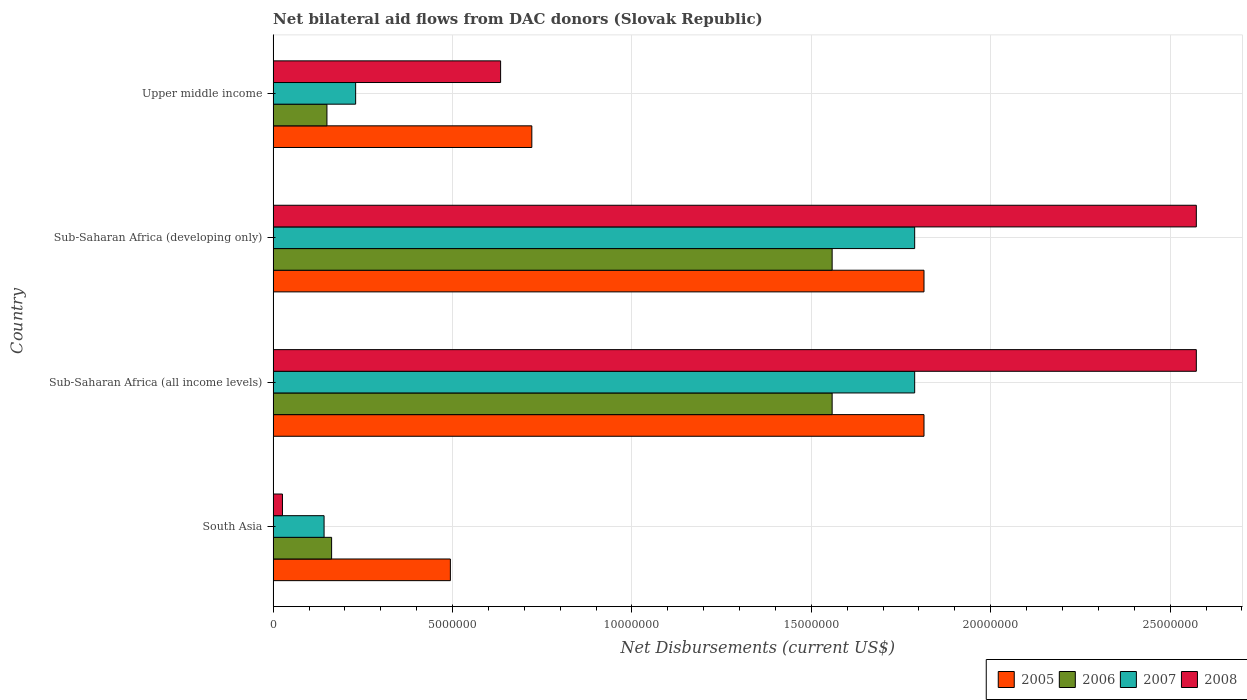How many different coloured bars are there?
Offer a terse response. 4. Are the number of bars per tick equal to the number of legend labels?
Offer a terse response. Yes. Are the number of bars on each tick of the Y-axis equal?
Give a very brief answer. Yes. How many bars are there on the 4th tick from the top?
Your answer should be compact. 4. In how many cases, is the number of bars for a given country not equal to the number of legend labels?
Offer a very short reply. 0. What is the net bilateral aid flows in 2007 in Sub-Saharan Africa (all income levels)?
Offer a very short reply. 1.79e+07. Across all countries, what is the maximum net bilateral aid flows in 2007?
Keep it short and to the point. 1.79e+07. Across all countries, what is the minimum net bilateral aid flows in 2008?
Your response must be concise. 2.60e+05. In which country was the net bilateral aid flows in 2008 maximum?
Give a very brief answer. Sub-Saharan Africa (all income levels). In which country was the net bilateral aid flows in 2008 minimum?
Provide a short and direct response. South Asia. What is the total net bilateral aid flows in 2006 in the graph?
Ensure brevity in your answer.  3.43e+07. What is the difference between the net bilateral aid flows in 2005 in Sub-Saharan Africa (all income levels) and that in Upper middle income?
Make the answer very short. 1.09e+07. What is the difference between the net bilateral aid flows in 2007 in Sub-Saharan Africa (developing only) and the net bilateral aid flows in 2008 in Upper middle income?
Make the answer very short. 1.15e+07. What is the average net bilateral aid flows in 2007 per country?
Provide a short and direct response. 9.87e+06. What is the difference between the net bilateral aid flows in 2005 and net bilateral aid flows in 2006 in South Asia?
Keep it short and to the point. 3.31e+06. What is the ratio of the net bilateral aid flows in 2007 in Sub-Saharan Africa (all income levels) to that in Upper middle income?
Ensure brevity in your answer.  7.77. What is the difference between the highest and the second highest net bilateral aid flows in 2006?
Give a very brief answer. 0. What is the difference between the highest and the lowest net bilateral aid flows in 2006?
Offer a very short reply. 1.41e+07. Is it the case that in every country, the sum of the net bilateral aid flows in 2005 and net bilateral aid flows in 2006 is greater than the sum of net bilateral aid flows in 2007 and net bilateral aid flows in 2008?
Your response must be concise. No. Is it the case that in every country, the sum of the net bilateral aid flows in 2005 and net bilateral aid flows in 2007 is greater than the net bilateral aid flows in 2006?
Ensure brevity in your answer.  Yes. How many bars are there?
Offer a very short reply. 16. How many countries are there in the graph?
Your answer should be compact. 4. Are the values on the major ticks of X-axis written in scientific E-notation?
Make the answer very short. No. Does the graph contain any zero values?
Your answer should be compact. No. Where does the legend appear in the graph?
Your response must be concise. Bottom right. How many legend labels are there?
Your answer should be very brief. 4. What is the title of the graph?
Give a very brief answer. Net bilateral aid flows from DAC donors (Slovak Republic). What is the label or title of the X-axis?
Keep it short and to the point. Net Disbursements (current US$). What is the Net Disbursements (current US$) of 2005 in South Asia?
Your response must be concise. 4.94e+06. What is the Net Disbursements (current US$) in 2006 in South Asia?
Keep it short and to the point. 1.63e+06. What is the Net Disbursements (current US$) in 2007 in South Asia?
Keep it short and to the point. 1.42e+06. What is the Net Disbursements (current US$) of 2005 in Sub-Saharan Africa (all income levels)?
Keep it short and to the point. 1.81e+07. What is the Net Disbursements (current US$) of 2006 in Sub-Saharan Africa (all income levels)?
Provide a succinct answer. 1.56e+07. What is the Net Disbursements (current US$) of 2007 in Sub-Saharan Africa (all income levels)?
Your answer should be very brief. 1.79e+07. What is the Net Disbursements (current US$) in 2008 in Sub-Saharan Africa (all income levels)?
Provide a short and direct response. 2.57e+07. What is the Net Disbursements (current US$) in 2005 in Sub-Saharan Africa (developing only)?
Keep it short and to the point. 1.81e+07. What is the Net Disbursements (current US$) of 2006 in Sub-Saharan Africa (developing only)?
Offer a very short reply. 1.56e+07. What is the Net Disbursements (current US$) in 2007 in Sub-Saharan Africa (developing only)?
Your answer should be very brief. 1.79e+07. What is the Net Disbursements (current US$) of 2008 in Sub-Saharan Africa (developing only)?
Keep it short and to the point. 2.57e+07. What is the Net Disbursements (current US$) in 2005 in Upper middle income?
Make the answer very short. 7.21e+06. What is the Net Disbursements (current US$) of 2006 in Upper middle income?
Your answer should be very brief. 1.50e+06. What is the Net Disbursements (current US$) in 2007 in Upper middle income?
Ensure brevity in your answer.  2.30e+06. What is the Net Disbursements (current US$) in 2008 in Upper middle income?
Offer a very short reply. 6.34e+06. Across all countries, what is the maximum Net Disbursements (current US$) of 2005?
Make the answer very short. 1.81e+07. Across all countries, what is the maximum Net Disbursements (current US$) in 2006?
Your answer should be very brief. 1.56e+07. Across all countries, what is the maximum Net Disbursements (current US$) in 2007?
Provide a short and direct response. 1.79e+07. Across all countries, what is the maximum Net Disbursements (current US$) in 2008?
Keep it short and to the point. 2.57e+07. Across all countries, what is the minimum Net Disbursements (current US$) of 2005?
Offer a very short reply. 4.94e+06. Across all countries, what is the minimum Net Disbursements (current US$) of 2006?
Ensure brevity in your answer.  1.50e+06. Across all countries, what is the minimum Net Disbursements (current US$) in 2007?
Your answer should be compact. 1.42e+06. Across all countries, what is the minimum Net Disbursements (current US$) in 2008?
Make the answer very short. 2.60e+05. What is the total Net Disbursements (current US$) in 2005 in the graph?
Your response must be concise. 4.84e+07. What is the total Net Disbursements (current US$) of 2006 in the graph?
Keep it short and to the point. 3.43e+07. What is the total Net Disbursements (current US$) of 2007 in the graph?
Your response must be concise. 3.95e+07. What is the total Net Disbursements (current US$) of 2008 in the graph?
Ensure brevity in your answer.  5.81e+07. What is the difference between the Net Disbursements (current US$) of 2005 in South Asia and that in Sub-Saharan Africa (all income levels)?
Give a very brief answer. -1.32e+07. What is the difference between the Net Disbursements (current US$) in 2006 in South Asia and that in Sub-Saharan Africa (all income levels)?
Give a very brief answer. -1.40e+07. What is the difference between the Net Disbursements (current US$) of 2007 in South Asia and that in Sub-Saharan Africa (all income levels)?
Your answer should be compact. -1.65e+07. What is the difference between the Net Disbursements (current US$) in 2008 in South Asia and that in Sub-Saharan Africa (all income levels)?
Your answer should be very brief. -2.55e+07. What is the difference between the Net Disbursements (current US$) in 2005 in South Asia and that in Sub-Saharan Africa (developing only)?
Your answer should be very brief. -1.32e+07. What is the difference between the Net Disbursements (current US$) of 2006 in South Asia and that in Sub-Saharan Africa (developing only)?
Offer a terse response. -1.40e+07. What is the difference between the Net Disbursements (current US$) in 2007 in South Asia and that in Sub-Saharan Africa (developing only)?
Provide a succinct answer. -1.65e+07. What is the difference between the Net Disbursements (current US$) in 2008 in South Asia and that in Sub-Saharan Africa (developing only)?
Your answer should be very brief. -2.55e+07. What is the difference between the Net Disbursements (current US$) of 2005 in South Asia and that in Upper middle income?
Make the answer very short. -2.27e+06. What is the difference between the Net Disbursements (current US$) of 2007 in South Asia and that in Upper middle income?
Provide a short and direct response. -8.80e+05. What is the difference between the Net Disbursements (current US$) in 2008 in South Asia and that in Upper middle income?
Make the answer very short. -6.08e+06. What is the difference between the Net Disbursements (current US$) of 2005 in Sub-Saharan Africa (all income levels) and that in Sub-Saharan Africa (developing only)?
Make the answer very short. 0. What is the difference between the Net Disbursements (current US$) in 2006 in Sub-Saharan Africa (all income levels) and that in Sub-Saharan Africa (developing only)?
Provide a succinct answer. 0. What is the difference between the Net Disbursements (current US$) in 2008 in Sub-Saharan Africa (all income levels) and that in Sub-Saharan Africa (developing only)?
Your answer should be very brief. 0. What is the difference between the Net Disbursements (current US$) in 2005 in Sub-Saharan Africa (all income levels) and that in Upper middle income?
Your response must be concise. 1.09e+07. What is the difference between the Net Disbursements (current US$) in 2006 in Sub-Saharan Africa (all income levels) and that in Upper middle income?
Offer a terse response. 1.41e+07. What is the difference between the Net Disbursements (current US$) in 2007 in Sub-Saharan Africa (all income levels) and that in Upper middle income?
Offer a terse response. 1.56e+07. What is the difference between the Net Disbursements (current US$) in 2008 in Sub-Saharan Africa (all income levels) and that in Upper middle income?
Give a very brief answer. 1.94e+07. What is the difference between the Net Disbursements (current US$) in 2005 in Sub-Saharan Africa (developing only) and that in Upper middle income?
Make the answer very short. 1.09e+07. What is the difference between the Net Disbursements (current US$) in 2006 in Sub-Saharan Africa (developing only) and that in Upper middle income?
Provide a succinct answer. 1.41e+07. What is the difference between the Net Disbursements (current US$) of 2007 in Sub-Saharan Africa (developing only) and that in Upper middle income?
Your answer should be compact. 1.56e+07. What is the difference between the Net Disbursements (current US$) of 2008 in Sub-Saharan Africa (developing only) and that in Upper middle income?
Give a very brief answer. 1.94e+07. What is the difference between the Net Disbursements (current US$) in 2005 in South Asia and the Net Disbursements (current US$) in 2006 in Sub-Saharan Africa (all income levels)?
Give a very brief answer. -1.06e+07. What is the difference between the Net Disbursements (current US$) in 2005 in South Asia and the Net Disbursements (current US$) in 2007 in Sub-Saharan Africa (all income levels)?
Provide a succinct answer. -1.29e+07. What is the difference between the Net Disbursements (current US$) in 2005 in South Asia and the Net Disbursements (current US$) in 2008 in Sub-Saharan Africa (all income levels)?
Offer a very short reply. -2.08e+07. What is the difference between the Net Disbursements (current US$) in 2006 in South Asia and the Net Disbursements (current US$) in 2007 in Sub-Saharan Africa (all income levels)?
Provide a short and direct response. -1.62e+07. What is the difference between the Net Disbursements (current US$) in 2006 in South Asia and the Net Disbursements (current US$) in 2008 in Sub-Saharan Africa (all income levels)?
Your answer should be compact. -2.41e+07. What is the difference between the Net Disbursements (current US$) in 2007 in South Asia and the Net Disbursements (current US$) in 2008 in Sub-Saharan Africa (all income levels)?
Give a very brief answer. -2.43e+07. What is the difference between the Net Disbursements (current US$) of 2005 in South Asia and the Net Disbursements (current US$) of 2006 in Sub-Saharan Africa (developing only)?
Your answer should be very brief. -1.06e+07. What is the difference between the Net Disbursements (current US$) in 2005 in South Asia and the Net Disbursements (current US$) in 2007 in Sub-Saharan Africa (developing only)?
Keep it short and to the point. -1.29e+07. What is the difference between the Net Disbursements (current US$) of 2005 in South Asia and the Net Disbursements (current US$) of 2008 in Sub-Saharan Africa (developing only)?
Your answer should be compact. -2.08e+07. What is the difference between the Net Disbursements (current US$) in 2006 in South Asia and the Net Disbursements (current US$) in 2007 in Sub-Saharan Africa (developing only)?
Provide a succinct answer. -1.62e+07. What is the difference between the Net Disbursements (current US$) of 2006 in South Asia and the Net Disbursements (current US$) of 2008 in Sub-Saharan Africa (developing only)?
Your response must be concise. -2.41e+07. What is the difference between the Net Disbursements (current US$) of 2007 in South Asia and the Net Disbursements (current US$) of 2008 in Sub-Saharan Africa (developing only)?
Offer a very short reply. -2.43e+07. What is the difference between the Net Disbursements (current US$) of 2005 in South Asia and the Net Disbursements (current US$) of 2006 in Upper middle income?
Keep it short and to the point. 3.44e+06. What is the difference between the Net Disbursements (current US$) in 2005 in South Asia and the Net Disbursements (current US$) in 2007 in Upper middle income?
Make the answer very short. 2.64e+06. What is the difference between the Net Disbursements (current US$) of 2005 in South Asia and the Net Disbursements (current US$) of 2008 in Upper middle income?
Give a very brief answer. -1.40e+06. What is the difference between the Net Disbursements (current US$) in 2006 in South Asia and the Net Disbursements (current US$) in 2007 in Upper middle income?
Ensure brevity in your answer.  -6.70e+05. What is the difference between the Net Disbursements (current US$) in 2006 in South Asia and the Net Disbursements (current US$) in 2008 in Upper middle income?
Your answer should be compact. -4.71e+06. What is the difference between the Net Disbursements (current US$) in 2007 in South Asia and the Net Disbursements (current US$) in 2008 in Upper middle income?
Provide a short and direct response. -4.92e+06. What is the difference between the Net Disbursements (current US$) of 2005 in Sub-Saharan Africa (all income levels) and the Net Disbursements (current US$) of 2006 in Sub-Saharan Africa (developing only)?
Make the answer very short. 2.56e+06. What is the difference between the Net Disbursements (current US$) in 2005 in Sub-Saharan Africa (all income levels) and the Net Disbursements (current US$) in 2007 in Sub-Saharan Africa (developing only)?
Provide a succinct answer. 2.60e+05. What is the difference between the Net Disbursements (current US$) of 2005 in Sub-Saharan Africa (all income levels) and the Net Disbursements (current US$) of 2008 in Sub-Saharan Africa (developing only)?
Offer a very short reply. -7.59e+06. What is the difference between the Net Disbursements (current US$) of 2006 in Sub-Saharan Africa (all income levels) and the Net Disbursements (current US$) of 2007 in Sub-Saharan Africa (developing only)?
Give a very brief answer. -2.30e+06. What is the difference between the Net Disbursements (current US$) of 2006 in Sub-Saharan Africa (all income levels) and the Net Disbursements (current US$) of 2008 in Sub-Saharan Africa (developing only)?
Your response must be concise. -1.02e+07. What is the difference between the Net Disbursements (current US$) of 2007 in Sub-Saharan Africa (all income levels) and the Net Disbursements (current US$) of 2008 in Sub-Saharan Africa (developing only)?
Offer a terse response. -7.85e+06. What is the difference between the Net Disbursements (current US$) of 2005 in Sub-Saharan Africa (all income levels) and the Net Disbursements (current US$) of 2006 in Upper middle income?
Your answer should be compact. 1.66e+07. What is the difference between the Net Disbursements (current US$) of 2005 in Sub-Saharan Africa (all income levels) and the Net Disbursements (current US$) of 2007 in Upper middle income?
Provide a short and direct response. 1.58e+07. What is the difference between the Net Disbursements (current US$) of 2005 in Sub-Saharan Africa (all income levels) and the Net Disbursements (current US$) of 2008 in Upper middle income?
Keep it short and to the point. 1.18e+07. What is the difference between the Net Disbursements (current US$) in 2006 in Sub-Saharan Africa (all income levels) and the Net Disbursements (current US$) in 2007 in Upper middle income?
Provide a succinct answer. 1.33e+07. What is the difference between the Net Disbursements (current US$) of 2006 in Sub-Saharan Africa (all income levels) and the Net Disbursements (current US$) of 2008 in Upper middle income?
Make the answer very short. 9.24e+06. What is the difference between the Net Disbursements (current US$) of 2007 in Sub-Saharan Africa (all income levels) and the Net Disbursements (current US$) of 2008 in Upper middle income?
Provide a succinct answer. 1.15e+07. What is the difference between the Net Disbursements (current US$) of 2005 in Sub-Saharan Africa (developing only) and the Net Disbursements (current US$) of 2006 in Upper middle income?
Ensure brevity in your answer.  1.66e+07. What is the difference between the Net Disbursements (current US$) in 2005 in Sub-Saharan Africa (developing only) and the Net Disbursements (current US$) in 2007 in Upper middle income?
Your answer should be very brief. 1.58e+07. What is the difference between the Net Disbursements (current US$) of 2005 in Sub-Saharan Africa (developing only) and the Net Disbursements (current US$) of 2008 in Upper middle income?
Offer a very short reply. 1.18e+07. What is the difference between the Net Disbursements (current US$) of 2006 in Sub-Saharan Africa (developing only) and the Net Disbursements (current US$) of 2007 in Upper middle income?
Your response must be concise. 1.33e+07. What is the difference between the Net Disbursements (current US$) of 2006 in Sub-Saharan Africa (developing only) and the Net Disbursements (current US$) of 2008 in Upper middle income?
Provide a succinct answer. 9.24e+06. What is the difference between the Net Disbursements (current US$) of 2007 in Sub-Saharan Africa (developing only) and the Net Disbursements (current US$) of 2008 in Upper middle income?
Keep it short and to the point. 1.15e+07. What is the average Net Disbursements (current US$) in 2005 per country?
Offer a terse response. 1.21e+07. What is the average Net Disbursements (current US$) of 2006 per country?
Ensure brevity in your answer.  8.57e+06. What is the average Net Disbursements (current US$) in 2007 per country?
Ensure brevity in your answer.  9.87e+06. What is the average Net Disbursements (current US$) in 2008 per country?
Make the answer very short. 1.45e+07. What is the difference between the Net Disbursements (current US$) in 2005 and Net Disbursements (current US$) in 2006 in South Asia?
Give a very brief answer. 3.31e+06. What is the difference between the Net Disbursements (current US$) in 2005 and Net Disbursements (current US$) in 2007 in South Asia?
Your answer should be compact. 3.52e+06. What is the difference between the Net Disbursements (current US$) in 2005 and Net Disbursements (current US$) in 2008 in South Asia?
Make the answer very short. 4.68e+06. What is the difference between the Net Disbursements (current US$) in 2006 and Net Disbursements (current US$) in 2007 in South Asia?
Keep it short and to the point. 2.10e+05. What is the difference between the Net Disbursements (current US$) of 2006 and Net Disbursements (current US$) of 2008 in South Asia?
Make the answer very short. 1.37e+06. What is the difference between the Net Disbursements (current US$) in 2007 and Net Disbursements (current US$) in 2008 in South Asia?
Your answer should be very brief. 1.16e+06. What is the difference between the Net Disbursements (current US$) in 2005 and Net Disbursements (current US$) in 2006 in Sub-Saharan Africa (all income levels)?
Keep it short and to the point. 2.56e+06. What is the difference between the Net Disbursements (current US$) of 2005 and Net Disbursements (current US$) of 2007 in Sub-Saharan Africa (all income levels)?
Your response must be concise. 2.60e+05. What is the difference between the Net Disbursements (current US$) of 2005 and Net Disbursements (current US$) of 2008 in Sub-Saharan Africa (all income levels)?
Offer a terse response. -7.59e+06. What is the difference between the Net Disbursements (current US$) of 2006 and Net Disbursements (current US$) of 2007 in Sub-Saharan Africa (all income levels)?
Your response must be concise. -2.30e+06. What is the difference between the Net Disbursements (current US$) in 2006 and Net Disbursements (current US$) in 2008 in Sub-Saharan Africa (all income levels)?
Provide a short and direct response. -1.02e+07. What is the difference between the Net Disbursements (current US$) in 2007 and Net Disbursements (current US$) in 2008 in Sub-Saharan Africa (all income levels)?
Your response must be concise. -7.85e+06. What is the difference between the Net Disbursements (current US$) in 2005 and Net Disbursements (current US$) in 2006 in Sub-Saharan Africa (developing only)?
Offer a very short reply. 2.56e+06. What is the difference between the Net Disbursements (current US$) of 2005 and Net Disbursements (current US$) of 2008 in Sub-Saharan Africa (developing only)?
Provide a short and direct response. -7.59e+06. What is the difference between the Net Disbursements (current US$) of 2006 and Net Disbursements (current US$) of 2007 in Sub-Saharan Africa (developing only)?
Provide a short and direct response. -2.30e+06. What is the difference between the Net Disbursements (current US$) of 2006 and Net Disbursements (current US$) of 2008 in Sub-Saharan Africa (developing only)?
Offer a terse response. -1.02e+07. What is the difference between the Net Disbursements (current US$) of 2007 and Net Disbursements (current US$) of 2008 in Sub-Saharan Africa (developing only)?
Your answer should be very brief. -7.85e+06. What is the difference between the Net Disbursements (current US$) in 2005 and Net Disbursements (current US$) in 2006 in Upper middle income?
Give a very brief answer. 5.71e+06. What is the difference between the Net Disbursements (current US$) in 2005 and Net Disbursements (current US$) in 2007 in Upper middle income?
Ensure brevity in your answer.  4.91e+06. What is the difference between the Net Disbursements (current US$) of 2005 and Net Disbursements (current US$) of 2008 in Upper middle income?
Provide a short and direct response. 8.70e+05. What is the difference between the Net Disbursements (current US$) of 2006 and Net Disbursements (current US$) of 2007 in Upper middle income?
Your response must be concise. -8.00e+05. What is the difference between the Net Disbursements (current US$) in 2006 and Net Disbursements (current US$) in 2008 in Upper middle income?
Give a very brief answer. -4.84e+06. What is the difference between the Net Disbursements (current US$) in 2007 and Net Disbursements (current US$) in 2008 in Upper middle income?
Your answer should be very brief. -4.04e+06. What is the ratio of the Net Disbursements (current US$) in 2005 in South Asia to that in Sub-Saharan Africa (all income levels)?
Provide a succinct answer. 0.27. What is the ratio of the Net Disbursements (current US$) of 2006 in South Asia to that in Sub-Saharan Africa (all income levels)?
Your response must be concise. 0.1. What is the ratio of the Net Disbursements (current US$) in 2007 in South Asia to that in Sub-Saharan Africa (all income levels)?
Keep it short and to the point. 0.08. What is the ratio of the Net Disbursements (current US$) of 2008 in South Asia to that in Sub-Saharan Africa (all income levels)?
Your response must be concise. 0.01. What is the ratio of the Net Disbursements (current US$) in 2005 in South Asia to that in Sub-Saharan Africa (developing only)?
Your response must be concise. 0.27. What is the ratio of the Net Disbursements (current US$) of 2006 in South Asia to that in Sub-Saharan Africa (developing only)?
Your answer should be very brief. 0.1. What is the ratio of the Net Disbursements (current US$) in 2007 in South Asia to that in Sub-Saharan Africa (developing only)?
Your answer should be compact. 0.08. What is the ratio of the Net Disbursements (current US$) in 2008 in South Asia to that in Sub-Saharan Africa (developing only)?
Keep it short and to the point. 0.01. What is the ratio of the Net Disbursements (current US$) of 2005 in South Asia to that in Upper middle income?
Ensure brevity in your answer.  0.69. What is the ratio of the Net Disbursements (current US$) in 2006 in South Asia to that in Upper middle income?
Give a very brief answer. 1.09. What is the ratio of the Net Disbursements (current US$) in 2007 in South Asia to that in Upper middle income?
Make the answer very short. 0.62. What is the ratio of the Net Disbursements (current US$) in 2008 in South Asia to that in Upper middle income?
Your answer should be very brief. 0.04. What is the ratio of the Net Disbursements (current US$) of 2005 in Sub-Saharan Africa (all income levels) to that in Sub-Saharan Africa (developing only)?
Offer a very short reply. 1. What is the ratio of the Net Disbursements (current US$) of 2005 in Sub-Saharan Africa (all income levels) to that in Upper middle income?
Your response must be concise. 2.52. What is the ratio of the Net Disbursements (current US$) of 2006 in Sub-Saharan Africa (all income levels) to that in Upper middle income?
Offer a very short reply. 10.39. What is the ratio of the Net Disbursements (current US$) of 2007 in Sub-Saharan Africa (all income levels) to that in Upper middle income?
Give a very brief answer. 7.77. What is the ratio of the Net Disbursements (current US$) of 2008 in Sub-Saharan Africa (all income levels) to that in Upper middle income?
Give a very brief answer. 4.06. What is the ratio of the Net Disbursements (current US$) in 2005 in Sub-Saharan Africa (developing only) to that in Upper middle income?
Your response must be concise. 2.52. What is the ratio of the Net Disbursements (current US$) in 2006 in Sub-Saharan Africa (developing only) to that in Upper middle income?
Make the answer very short. 10.39. What is the ratio of the Net Disbursements (current US$) in 2007 in Sub-Saharan Africa (developing only) to that in Upper middle income?
Your answer should be compact. 7.77. What is the ratio of the Net Disbursements (current US$) of 2008 in Sub-Saharan Africa (developing only) to that in Upper middle income?
Offer a terse response. 4.06. What is the difference between the highest and the second highest Net Disbursements (current US$) of 2006?
Offer a very short reply. 0. What is the difference between the highest and the second highest Net Disbursements (current US$) of 2007?
Offer a very short reply. 0. What is the difference between the highest and the lowest Net Disbursements (current US$) of 2005?
Make the answer very short. 1.32e+07. What is the difference between the highest and the lowest Net Disbursements (current US$) of 2006?
Give a very brief answer. 1.41e+07. What is the difference between the highest and the lowest Net Disbursements (current US$) in 2007?
Ensure brevity in your answer.  1.65e+07. What is the difference between the highest and the lowest Net Disbursements (current US$) of 2008?
Ensure brevity in your answer.  2.55e+07. 